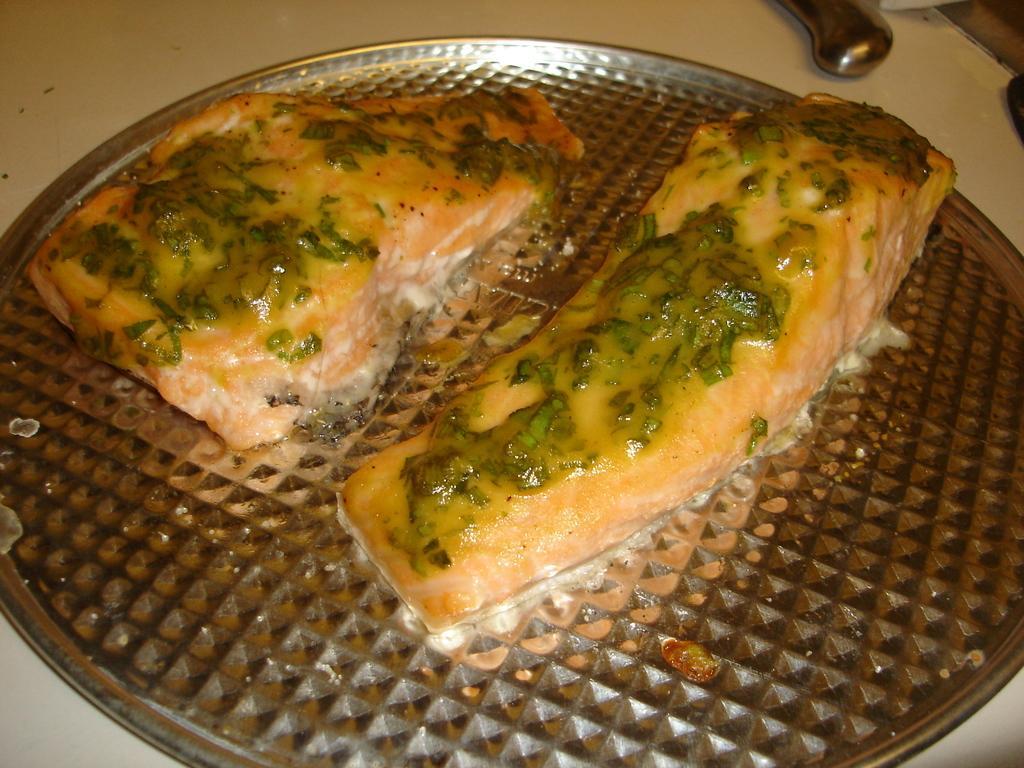Please provide a concise description of this image. In this image we can see some food item kept on the plate and we can see knife placed on the white surface. 